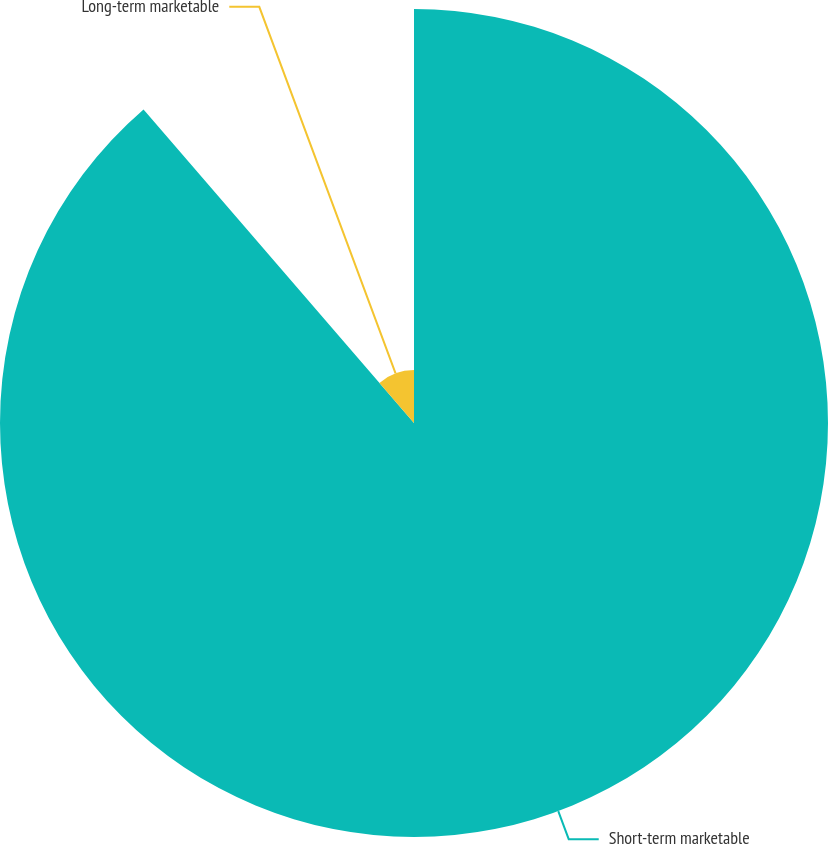Convert chart. <chart><loc_0><loc_0><loc_500><loc_500><pie_chart><fcel>Short-term marketable<fcel>Long-term marketable<nl><fcel>88.67%<fcel>11.33%<nl></chart> 